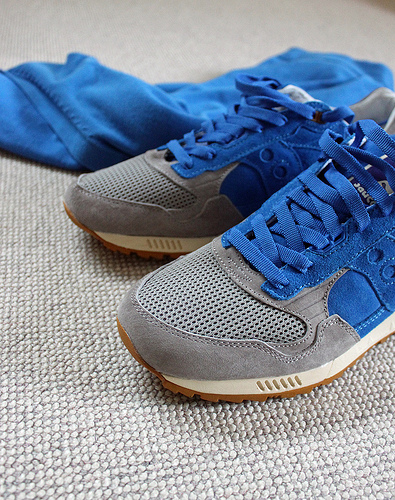<image>
Can you confirm if the tennis shoe is to the left of the shirt? No. The tennis shoe is not to the left of the shirt. From this viewpoint, they have a different horizontal relationship. Is there a shirt above the shoes? No. The shirt is not positioned above the shoes. The vertical arrangement shows a different relationship. Where is the tennis shoes in relation to the carpet? Is it above the carpet? No. The tennis shoes is not positioned above the carpet. The vertical arrangement shows a different relationship. 